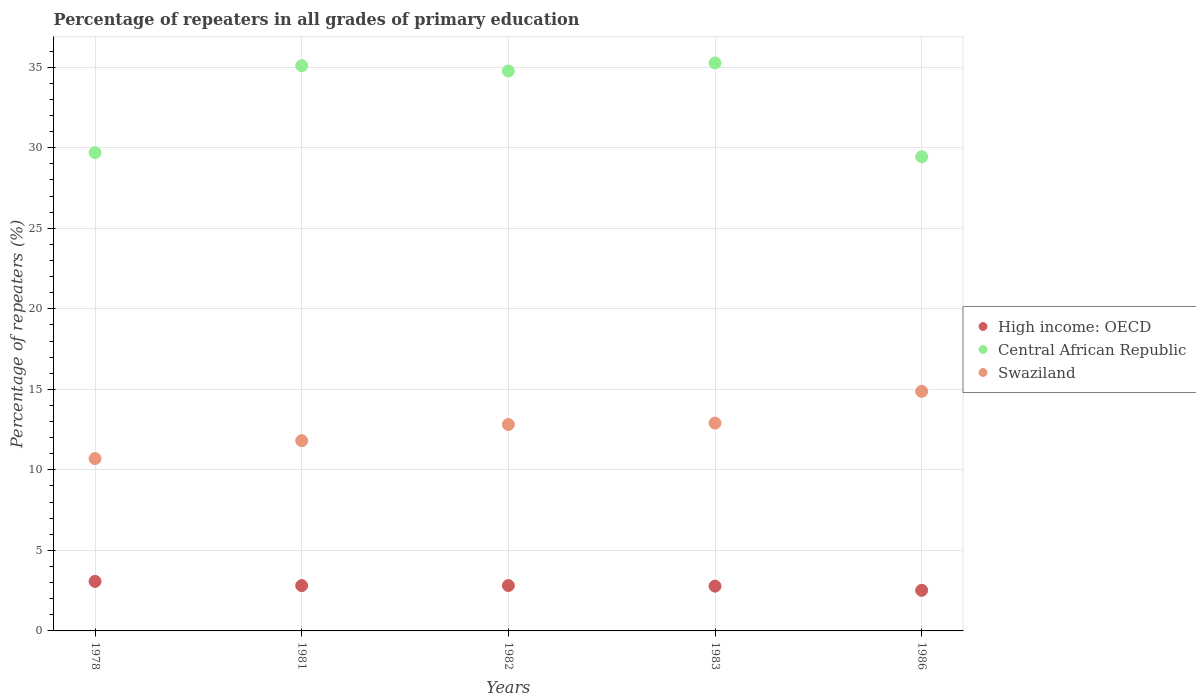What is the percentage of repeaters in Central African Republic in 1978?
Keep it short and to the point. 29.7. Across all years, what is the maximum percentage of repeaters in Swaziland?
Provide a succinct answer. 14.87. Across all years, what is the minimum percentage of repeaters in Swaziland?
Make the answer very short. 10.7. In which year was the percentage of repeaters in Swaziland maximum?
Offer a very short reply. 1986. In which year was the percentage of repeaters in Swaziland minimum?
Your response must be concise. 1978. What is the total percentage of repeaters in Swaziland in the graph?
Ensure brevity in your answer.  63.11. What is the difference between the percentage of repeaters in Swaziland in 1982 and that in 1986?
Give a very brief answer. -2.06. What is the difference between the percentage of repeaters in High income: OECD in 1983 and the percentage of repeaters in Central African Republic in 1982?
Provide a short and direct response. -31.99. What is the average percentage of repeaters in High income: OECD per year?
Your response must be concise. 2.8. In the year 1982, what is the difference between the percentage of repeaters in Central African Republic and percentage of repeaters in Swaziland?
Give a very brief answer. 21.95. What is the ratio of the percentage of repeaters in High income: OECD in 1978 to that in 1986?
Your response must be concise. 1.22. Is the difference between the percentage of repeaters in Central African Republic in 1978 and 1983 greater than the difference between the percentage of repeaters in Swaziland in 1978 and 1983?
Offer a very short reply. No. What is the difference between the highest and the second highest percentage of repeaters in Central African Republic?
Give a very brief answer. 0.17. What is the difference between the highest and the lowest percentage of repeaters in High income: OECD?
Provide a succinct answer. 0.55. Is the percentage of repeaters in Central African Republic strictly greater than the percentage of repeaters in Swaziland over the years?
Give a very brief answer. Yes. Is the percentage of repeaters in Central African Republic strictly less than the percentage of repeaters in High income: OECD over the years?
Your response must be concise. No. How many years are there in the graph?
Keep it short and to the point. 5. Does the graph contain any zero values?
Offer a terse response. No. Where does the legend appear in the graph?
Your answer should be compact. Center right. How many legend labels are there?
Your response must be concise. 3. What is the title of the graph?
Provide a short and direct response. Percentage of repeaters in all grades of primary education. What is the label or title of the Y-axis?
Your answer should be compact. Percentage of repeaters (%). What is the Percentage of repeaters (%) of High income: OECD in 1978?
Provide a short and direct response. 3.08. What is the Percentage of repeaters (%) in Central African Republic in 1978?
Provide a succinct answer. 29.7. What is the Percentage of repeaters (%) in Swaziland in 1978?
Make the answer very short. 10.7. What is the Percentage of repeaters (%) of High income: OECD in 1981?
Your answer should be very brief. 2.81. What is the Percentage of repeaters (%) of Central African Republic in 1981?
Offer a very short reply. 35.1. What is the Percentage of repeaters (%) in Swaziland in 1981?
Your answer should be compact. 11.81. What is the Percentage of repeaters (%) of High income: OECD in 1982?
Your response must be concise. 2.82. What is the Percentage of repeaters (%) of Central African Republic in 1982?
Offer a very short reply. 34.77. What is the Percentage of repeaters (%) of Swaziland in 1982?
Your response must be concise. 12.81. What is the Percentage of repeaters (%) in High income: OECD in 1983?
Your response must be concise. 2.78. What is the Percentage of repeaters (%) in Central African Republic in 1983?
Offer a terse response. 35.27. What is the Percentage of repeaters (%) in Swaziland in 1983?
Offer a very short reply. 12.9. What is the Percentage of repeaters (%) in High income: OECD in 1986?
Your answer should be compact. 2.52. What is the Percentage of repeaters (%) in Central African Republic in 1986?
Provide a short and direct response. 29.44. What is the Percentage of repeaters (%) in Swaziland in 1986?
Make the answer very short. 14.87. Across all years, what is the maximum Percentage of repeaters (%) in High income: OECD?
Ensure brevity in your answer.  3.08. Across all years, what is the maximum Percentage of repeaters (%) in Central African Republic?
Your answer should be compact. 35.27. Across all years, what is the maximum Percentage of repeaters (%) of Swaziland?
Offer a very short reply. 14.87. Across all years, what is the minimum Percentage of repeaters (%) of High income: OECD?
Give a very brief answer. 2.52. Across all years, what is the minimum Percentage of repeaters (%) in Central African Republic?
Provide a succinct answer. 29.44. Across all years, what is the minimum Percentage of repeaters (%) of Swaziland?
Give a very brief answer. 10.7. What is the total Percentage of repeaters (%) in High income: OECD in the graph?
Make the answer very short. 14.01. What is the total Percentage of repeaters (%) in Central African Republic in the graph?
Provide a short and direct response. 164.27. What is the total Percentage of repeaters (%) in Swaziland in the graph?
Make the answer very short. 63.11. What is the difference between the Percentage of repeaters (%) of High income: OECD in 1978 and that in 1981?
Your response must be concise. 0.26. What is the difference between the Percentage of repeaters (%) of Central African Republic in 1978 and that in 1981?
Keep it short and to the point. -5.4. What is the difference between the Percentage of repeaters (%) in Swaziland in 1978 and that in 1981?
Ensure brevity in your answer.  -1.11. What is the difference between the Percentage of repeaters (%) in High income: OECD in 1978 and that in 1982?
Ensure brevity in your answer.  0.26. What is the difference between the Percentage of repeaters (%) of Central African Republic in 1978 and that in 1982?
Provide a succinct answer. -5.07. What is the difference between the Percentage of repeaters (%) in Swaziland in 1978 and that in 1982?
Your response must be concise. -2.11. What is the difference between the Percentage of repeaters (%) in High income: OECD in 1978 and that in 1983?
Provide a short and direct response. 0.3. What is the difference between the Percentage of repeaters (%) in Central African Republic in 1978 and that in 1983?
Provide a succinct answer. -5.57. What is the difference between the Percentage of repeaters (%) of Swaziland in 1978 and that in 1983?
Make the answer very short. -2.2. What is the difference between the Percentage of repeaters (%) of High income: OECD in 1978 and that in 1986?
Provide a succinct answer. 0.55. What is the difference between the Percentage of repeaters (%) in Central African Republic in 1978 and that in 1986?
Provide a short and direct response. 0.26. What is the difference between the Percentage of repeaters (%) of Swaziland in 1978 and that in 1986?
Make the answer very short. -4.17. What is the difference between the Percentage of repeaters (%) of High income: OECD in 1981 and that in 1982?
Your response must be concise. -0. What is the difference between the Percentage of repeaters (%) in Central African Republic in 1981 and that in 1982?
Provide a succinct answer. 0.33. What is the difference between the Percentage of repeaters (%) in Swaziland in 1981 and that in 1982?
Your answer should be very brief. -1. What is the difference between the Percentage of repeaters (%) of High income: OECD in 1981 and that in 1983?
Your answer should be compact. 0.03. What is the difference between the Percentage of repeaters (%) in Central African Republic in 1981 and that in 1983?
Offer a very short reply. -0.17. What is the difference between the Percentage of repeaters (%) in Swaziland in 1981 and that in 1983?
Provide a short and direct response. -1.09. What is the difference between the Percentage of repeaters (%) in High income: OECD in 1981 and that in 1986?
Keep it short and to the point. 0.29. What is the difference between the Percentage of repeaters (%) of Central African Republic in 1981 and that in 1986?
Offer a very short reply. 5.66. What is the difference between the Percentage of repeaters (%) in Swaziland in 1981 and that in 1986?
Ensure brevity in your answer.  -3.06. What is the difference between the Percentage of repeaters (%) in High income: OECD in 1982 and that in 1983?
Keep it short and to the point. 0.04. What is the difference between the Percentage of repeaters (%) in Central African Republic in 1982 and that in 1983?
Make the answer very short. -0.5. What is the difference between the Percentage of repeaters (%) of Swaziland in 1982 and that in 1983?
Your answer should be very brief. -0.09. What is the difference between the Percentage of repeaters (%) of High income: OECD in 1982 and that in 1986?
Give a very brief answer. 0.3. What is the difference between the Percentage of repeaters (%) in Central African Republic in 1982 and that in 1986?
Provide a short and direct response. 5.33. What is the difference between the Percentage of repeaters (%) of Swaziland in 1982 and that in 1986?
Keep it short and to the point. -2.06. What is the difference between the Percentage of repeaters (%) of High income: OECD in 1983 and that in 1986?
Offer a terse response. 0.26. What is the difference between the Percentage of repeaters (%) of Central African Republic in 1983 and that in 1986?
Your answer should be very brief. 5.82. What is the difference between the Percentage of repeaters (%) in Swaziland in 1983 and that in 1986?
Make the answer very short. -1.97. What is the difference between the Percentage of repeaters (%) of High income: OECD in 1978 and the Percentage of repeaters (%) of Central African Republic in 1981?
Your answer should be very brief. -32.02. What is the difference between the Percentage of repeaters (%) of High income: OECD in 1978 and the Percentage of repeaters (%) of Swaziland in 1981?
Provide a short and direct response. -8.74. What is the difference between the Percentage of repeaters (%) of Central African Republic in 1978 and the Percentage of repeaters (%) of Swaziland in 1981?
Your response must be concise. 17.88. What is the difference between the Percentage of repeaters (%) of High income: OECD in 1978 and the Percentage of repeaters (%) of Central African Republic in 1982?
Make the answer very short. -31.69. What is the difference between the Percentage of repeaters (%) in High income: OECD in 1978 and the Percentage of repeaters (%) in Swaziland in 1982?
Make the answer very short. -9.74. What is the difference between the Percentage of repeaters (%) of Central African Republic in 1978 and the Percentage of repeaters (%) of Swaziland in 1982?
Give a very brief answer. 16.88. What is the difference between the Percentage of repeaters (%) of High income: OECD in 1978 and the Percentage of repeaters (%) of Central African Republic in 1983?
Offer a very short reply. -32.19. What is the difference between the Percentage of repeaters (%) of High income: OECD in 1978 and the Percentage of repeaters (%) of Swaziland in 1983?
Your answer should be compact. -9.83. What is the difference between the Percentage of repeaters (%) of Central African Republic in 1978 and the Percentage of repeaters (%) of Swaziland in 1983?
Your answer should be very brief. 16.79. What is the difference between the Percentage of repeaters (%) of High income: OECD in 1978 and the Percentage of repeaters (%) of Central African Republic in 1986?
Give a very brief answer. -26.36. What is the difference between the Percentage of repeaters (%) in High income: OECD in 1978 and the Percentage of repeaters (%) in Swaziland in 1986?
Give a very brief answer. -11.8. What is the difference between the Percentage of repeaters (%) of Central African Republic in 1978 and the Percentage of repeaters (%) of Swaziland in 1986?
Provide a short and direct response. 14.82. What is the difference between the Percentage of repeaters (%) in High income: OECD in 1981 and the Percentage of repeaters (%) in Central African Republic in 1982?
Provide a short and direct response. -31.95. What is the difference between the Percentage of repeaters (%) of High income: OECD in 1981 and the Percentage of repeaters (%) of Swaziland in 1982?
Offer a terse response. -10. What is the difference between the Percentage of repeaters (%) in Central African Republic in 1981 and the Percentage of repeaters (%) in Swaziland in 1982?
Keep it short and to the point. 22.28. What is the difference between the Percentage of repeaters (%) in High income: OECD in 1981 and the Percentage of repeaters (%) in Central African Republic in 1983?
Make the answer very short. -32.45. What is the difference between the Percentage of repeaters (%) in High income: OECD in 1981 and the Percentage of repeaters (%) in Swaziland in 1983?
Your answer should be compact. -10.09. What is the difference between the Percentage of repeaters (%) of Central African Republic in 1981 and the Percentage of repeaters (%) of Swaziland in 1983?
Your answer should be compact. 22.19. What is the difference between the Percentage of repeaters (%) of High income: OECD in 1981 and the Percentage of repeaters (%) of Central African Republic in 1986?
Your response must be concise. -26.63. What is the difference between the Percentage of repeaters (%) in High income: OECD in 1981 and the Percentage of repeaters (%) in Swaziland in 1986?
Ensure brevity in your answer.  -12.06. What is the difference between the Percentage of repeaters (%) in Central African Republic in 1981 and the Percentage of repeaters (%) in Swaziland in 1986?
Offer a very short reply. 20.22. What is the difference between the Percentage of repeaters (%) of High income: OECD in 1982 and the Percentage of repeaters (%) of Central African Republic in 1983?
Provide a succinct answer. -32.45. What is the difference between the Percentage of repeaters (%) in High income: OECD in 1982 and the Percentage of repeaters (%) in Swaziland in 1983?
Your response must be concise. -10.09. What is the difference between the Percentage of repeaters (%) in Central African Republic in 1982 and the Percentage of repeaters (%) in Swaziland in 1983?
Your answer should be compact. 21.86. What is the difference between the Percentage of repeaters (%) in High income: OECD in 1982 and the Percentage of repeaters (%) in Central African Republic in 1986?
Provide a succinct answer. -26.62. What is the difference between the Percentage of repeaters (%) in High income: OECD in 1982 and the Percentage of repeaters (%) in Swaziland in 1986?
Your answer should be very brief. -12.06. What is the difference between the Percentage of repeaters (%) of Central African Republic in 1982 and the Percentage of repeaters (%) of Swaziland in 1986?
Your answer should be compact. 19.89. What is the difference between the Percentage of repeaters (%) of High income: OECD in 1983 and the Percentage of repeaters (%) of Central African Republic in 1986?
Offer a terse response. -26.66. What is the difference between the Percentage of repeaters (%) of High income: OECD in 1983 and the Percentage of repeaters (%) of Swaziland in 1986?
Your answer should be compact. -12.09. What is the difference between the Percentage of repeaters (%) in Central African Republic in 1983 and the Percentage of repeaters (%) in Swaziland in 1986?
Make the answer very short. 20.39. What is the average Percentage of repeaters (%) of High income: OECD per year?
Keep it short and to the point. 2.8. What is the average Percentage of repeaters (%) of Central African Republic per year?
Ensure brevity in your answer.  32.85. What is the average Percentage of repeaters (%) of Swaziland per year?
Offer a very short reply. 12.62. In the year 1978, what is the difference between the Percentage of repeaters (%) of High income: OECD and Percentage of repeaters (%) of Central African Republic?
Provide a succinct answer. -26.62. In the year 1978, what is the difference between the Percentage of repeaters (%) in High income: OECD and Percentage of repeaters (%) in Swaziland?
Your answer should be very brief. -7.62. In the year 1978, what is the difference between the Percentage of repeaters (%) in Central African Republic and Percentage of repeaters (%) in Swaziland?
Make the answer very short. 19. In the year 1981, what is the difference between the Percentage of repeaters (%) of High income: OECD and Percentage of repeaters (%) of Central African Republic?
Ensure brevity in your answer.  -32.28. In the year 1981, what is the difference between the Percentage of repeaters (%) of High income: OECD and Percentage of repeaters (%) of Swaziland?
Keep it short and to the point. -9. In the year 1981, what is the difference between the Percentage of repeaters (%) of Central African Republic and Percentage of repeaters (%) of Swaziland?
Your response must be concise. 23.29. In the year 1982, what is the difference between the Percentage of repeaters (%) of High income: OECD and Percentage of repeaters (%) of Central African Republic?
Give a very brief answer. -31.95. In the year 1982, what is the difference between the Percentage of repeaters (%) of High income: OECD and Percentage of repeaters (%) of Swaziland?
Provide a succinct answer. -10. In the year 1982, what is the difference between the Percentage of repeaters (%) in Central African Republic and Percentage of repeaters (%) in Swaziland?
Your response must be concise. 21.95. In the year 1983, what is the difference between the Percentage of repeaters (%) in High income: OECD and Percentage of repeaters (%) in Central African Republic?
Keep it short and to the point. -32.49. In the year 1983, what is the difference between the Percentage of repeaters (%) in High income: OECD and Percentage of repeaters (%) in Swaziland?
Make the answer very short. -10.12. In the year 1983, what is the difference between the Percentage of repeaters (%) of Central African Republic and Percentage of repeaters (%) of Swaziland?
Offer a very short reply. 22.36. In the year 1986, what is the difference between the Percentage of repeaters (%) of High income: OECD and Percentage of repeaters (%) of Central African Republic?
Ensure brevity in your answer.  -26.92. In the year 1986, what is the difference between the Percentage of repeaters (%) of High income: OECD and Percentage of repeaters (%) of Swaziland?
Your response must be concise. -12.35. In the year 1986, what is the difference between the Percentage of repeaters (%) of Central African Republic and Percentage of repeaters (%) of Swaziland?
Your answer should be very brief. 14.57. What is the ratio of the Percentage of repeaters (%) in High income: OECD in 1978 to that in 1981?
Your answer should be very brief. 1.09. What is the ratio of the Percentage of repeaters (%) of Central African Republic in 1978 to that in 1981?
Provide a succinct answer. 0.85. What is the ratio of the Percentage of repeaters (%) of Swaziland in 1978 to that in 1981?
Offer a very short reply. 0.91. What is the ratio of the Percentage of repeaters (%) of High income: OECD in 1978 to that in 1982?
Provide a short and direct response. 1.09. What is the ratio of the Percentage of repeaters (%) in Central African Republic in 1978 to that in 1982?
Ensure brevity in your answer.  0.85. What is the ratio of the Percentage of repeaters (%) of Swaziland in 1978 to that in 1982?
Provide a short and direct response. 0.83. What is the ratio of the Percentage of repeaters (%) in High income: OECD in 1978 to that in 1983?
Provide a succinct answer. 1.11. What is the ratio of the Percentage of repeaters (%) in Central African Republic in 1978 to that in 1983?
Your answer should be very brief. 0.84. What is the ratio of the Percentage of repeaters (%) in Swaziland in 1978 to that in 1983?
Offer a very short reply. 0.83. What is the ratio of the Percentage of repeaters (%) of High income: OECD in 1978 to that in 1986?
Make the answer very short. 1.22. What is the ratio of the Percentage of repeaters (%) in Central African Republic in 1978 to that in 1986?
Your answer should be very brief. 1.01. What is the ratio of the Percentage of repeaters (%) of Swaziland in 1978 to that in 1986?
Ensure brevity in your answer.  0.72. What is the ratio of the Percentage of repeaters (%) in High income: OECD in 1981 to that in 1982?
Your response must be concise. 1. What is the ratio of the Percentage of repeaters (%) of Central African Republic in 1981 to that in 1982?
Offer a terse response. 1.01. What is the ratio of the Percentage of repeaters (%) in Swaziland in 1981 to that in 1982?
Keep it short and to the point. 0.92. What is the ratio of the Percentage of repeaters (%) in High income: OECD in 1981 to that in 1983?
Your answer should be very brief. 1.01. What is the ratio of the Percentage of repeaters (%) of Central African Republic in 1981 to that in 1983?
Your answer should be compact. 1. What is the ratio of the Percentage of repeaters (%) of Swaziland in 1981 to that in 1983?
Give a very brief answer. 0.92. What is the ratio of the Percentage of repeaters (%) of High income: OECD in 1981 to that in 1986?
Give a very brief answer. 1.12. What is the ratio of the Percentage of repeaters (%) of Central African Republic in 1981 to that in 1986?
Keep it short and to the point. 1.19. What is the ratio of the Percentage of repeaters (%) of Swaziland in 1981 to that in 1986?
Offer a very short reply. 0.79. What is the ratio of the Percentage of repeaters (%) in Central African Republic in 1982 to that in 1983?
Offer a very short reply. 0.99. What is the ratio of the Percentage of repeaters (%) in Swaziland in 1982 to that in 1983?
Your answer should be compact. 0.99. What is the ratio of the Percentage of repeaters (%) in High income: OECD in 1982 to that in 1986?
Ensure brevity in your answer.  1.12. What is the ratio of the Percentage of repeaters (%) of Central African Republic in 1982 to that in 1986?
Your response must be concise. 1.18. What is the ratio of the Percentage of repeaters (%) of Swaziland in 1982 to that in 1986?
Provide a short and direct response. 0.86. What is the ratio of the Percentage of repeaters (%) in High income: OECD in 1983 to that in 1986?
Provide a succinct answer. 1.1. What is the ratio of the Percentage of repeaters (%) of Central African Republic in 1983 to that in 1986?
Your response must be concise. 1.2. What is the ratio of the Percentage of repeaters (%) in Swaziland in 1983 to that in 1986?
Your answer should be very brief. 0.87. What is the difference between the highest and the second highest Percentage of repeaters (%) in High income: OECD?
Provide a short and direct response. 0.26. What is the difference between the highest and the second highest Percentage of repeaters (%) in Central African Republic?
Ensure brevity in your answer.  0.17. What is the difference between the highest and the second highest Percentage of repeaters (%) of Swaziland?
Keep it short and to the point. 1.97. What is the difference between the highest and the lowest Percentage of repeaters (%) in High income: OECD?
Provide a short and direct response. 0.55. What is the difference between the highest and the lowest Percentage of repeaters (%) of Central African Republic?
Provide a short and direct response. 5.82. What is the difference between the highest and the lowest Percentage of repeaters (%) of Swaziland?
Make the answer very short. 4.17. 